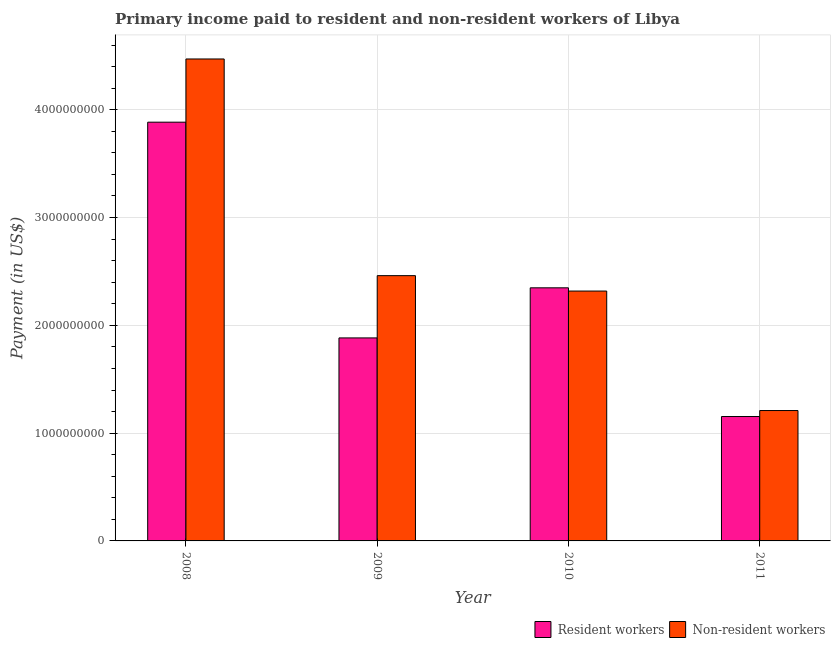How many groups of bars are there?
Ensure brevity in your answer.  4. Are the number of bars per tick equal to the number of legend labels?
Provide a succinct answer. Yes. How many bars are there on the 4th tick from the left?
Give a very brief answer. 2. How many bars are there on the 4th tick from the right?
Give a very brief answer. 2. What is the label of the 1st group of bars from the left?
Ensure brevity in your answer.  2008. In how many cases, is the number of bars for a given year not equal to the number of legend labels?
Give a very brief answer. 0. What is the payment made to non-resident workers in 2009?
Provide a succinct answer. 2.46e+09. Across all years, what is the maximum payment made to resident workers?
Give a very brief answer. 3.88e+09. Across all years, what is the minimum payment made to non-resident workers?
Keep it short and to the point. 1.21e+09. What is the total payment made to non-resident workers in the graph?
Provide a succinct answer. 1.05e+1. What is the difference between the payment made to resident workers in 2009 and that in 2011?
Make the answer very short. 7.29e+08. What is the difference between the payment made to non-resident workers in 2011 and the payment made to resident workers in 2009?
Your answer should be very brief. -1.25e+09. What is the average payment made to resident workers per year?
Make the answer very short. 2.32e+09. In how many years, is the payment made to resident workers greater than 2400000000 US$?
Offer a terse response. 1. What is the ratio of the payment made to resident workers in 2008 to that in 2010?
Your answer should be very brief. 1.65. Is the difference between the payment made to resident workers in 2010 and 2011 greater than the difference between the payment made to non-resident workers in 2010 and 2011?
Provide a short and direct response. No. What is the difference between the highest and the second highest payment made to non-resident workers?
Keep it short and to the point. 2.01e+09. What is the difference between the highest and the lowest payment made to resident workers?
Your answer should be very brief. 2.73e+09. What does the 2nd bar from the left in 2010 represents?
Make the answer very short. Non-resident workers. What does the 1st bar from the right in 2008 represents?
Make the answer very short. Non-resident workers. How many bars are there?
Give a very brief answer. 8. Are all the bars in the graph horizontal?
Keep it short and to the point. No. What is the difference between two consecutive major ticks on the Y-axis?
Your answer should be very brief. 1.00e+09. Are the values on the major ticks of Y-axis written in scientific E-notation?
Keep it short and to the point. No. Does the graph contain grids?
Your answer should be very brief. Yes. How many legend labels are there?
Make the answer very short. 2. How are the legend labels stacked?
Make the answer very short. Horizontal. What is the title of the graph?
Your response must be concise. Primary income paid to resident and non-resident workers of Libya. What is the label or title of the X-axis?
Keep it short and to the point. Year. What is the label or title of the Y-axis?
Your response must be concise. Payment (in US$). What is the Payment (in US$) in Resident workers in 2008?
Give a very brief answer. 3.88e+09. What is the Payment (in US$) in Non-resident workers in 2008?
Offer a very short reply. 4.47e+09. What is the Payment (in US$) in Resident workers in 2009?
Make the answer very short. 1.88e+09. What is the Payment (in US$) of Non-resident workers in 2009?
Your answer should be compact. 2.46e+09. What is the Payment (in US$) of Resident workers in 2010?
Your response must be concise. 2.35e+09. What is the Payment (in US$) of Non-resident workers in 2010?
Make the answer very short. 2.32e+09. What is the Payment (in US$) in Resident workers in 2011?
Your response must be concise. 1.15e+09. What is the Payment (in US$) of Non-resident workers in 2011?
Ensure brevity in your answer.  1.21e+09. Across all years, what is the maximum Payment (in US$) in Resident workers?
Provide a short and direct response. 3.88e+09. Across all years, what is the maximum Payment (in US$) of Non-resident workers?
Provide a short and direct response. 4.47e+09. Across all years, what is the minimum Payment (in US$) of Resident workers?
Provide a short and direct response. 1.15e+09. Across all years, what is the minimum Payment (in US$) of Non-resident workers?
Your answer should be compact. 1.21e+09. What is the total Payment (in US$) in Resident workers in the graph?
Your answer should be very brief. 9.27e+09. What is the total Payment (in US$) in Non-resident workers in the graph?
Provide a succinct answer. 1.05e+1. What is the difference between the Payment (in US$) in Resident workers in 2008 and that in 2009?
Offer a terse response. 2.00e+09. What is the difference between the Payment (in US$) in Non-resident workers in 2008 and that in 2009?
Your answer should be compact. 2.01e+09. What is the difference between the Payment (in US$) in Resident workers in 2008 and that in 2010?
Provide a short and direct response. 1.54e+09. What is the difference between the Payment (in US$) in Non-resident workers in 2008 and that in 2010?
Provide a short and direct response. 2.15e+09. What is the difference between the Payment (in US$) in Resident workers in 2008 and that in 2011?
Ensure brevity in your answer.  2.73e+09. What is the difference between the Payment (in US$) in Non-resident workers in 2008 and that in 2011?
Your response must be concise. 3.26e+09. What is the difference between the Payment (in US$) in Resident workers in 2009 and that in 2010?
Your answer should be very brief. -4.65e+08. What is the difference between the Payment (in US$) in Non-resident workers in 2009 and that in 2010?
Make the answer very short. 1.43e+08. What is the difference between the Payment (in US$) in Resident workers in 2009 and that in 2011?
Give a very brief answer. 7.29e+08. What is the difference between the Payment (in US$) of Non-resident workers in 2009 and that in 2011?
Offer a very short reply. 1.25e+09. What is the difference between the Payment (in US$) in Resident workers in 2010 and that in 2011?
Provide a short and direct response. 1.19e+09. What is the difference between the Payment (in US$) of Non-resident workers in 2010 and that in 2011?
Ensure brevity in your answer.  1.11e+09. What is the difference between the Payment (in US$) of Resident workers in 2008 and the Payment (in US$) of Non-resident workers in 2009?
Offer a very short reply. 1.42e+09. What is the difference between the Payment (in US$) of Resident workers in 2008 and the Payment (in US$) of Non-resident workers in 2010?
Provide a short and direct response. 1.57e+09. What is the difference between the Payment (in US$) in Resident workers in 2008 and the Payment (in US$) in Non-resident workers in 2011?
Keep it short and to the point. 2.68e+09. What is the difference between the Payment (in US$) of Resident workers in 2009 and the Payment (in US$) of Non-resident workers in 2010?
Your answer should be compact. -4.35e+08. What is the difference between the Payment (in US$) in Resident workers in 2009 and the Payment (in US$) in Non-resident workers in 2011?
Your response must be concise. 6.74e+08. What is the difference between the Payment (in US$) of Resident workers in 2010 and the Payment (in US$) of Non-resident workers in 2011?
Your answer should be very brief. 1.14e+09. What is the average Payment (in US$) in Resident workers per year?
Make the answer very short. 2.32e+09. What is the average Payment (in US$) of Non-resident workers per year?
Keep it short and to the point. 2.61e+09. In the year 2008, what is the difference between the Payment (in US$) in Resident workers and Payment (in US$) in Non-resident workers?
Give a very brief answer. -5.86e+08. In the year 2009, what is the difference between the Payment (in US$) of Resident workers and Payment (in US$) of Non-resident workers?
Offer a terse response. -5.78e+08. In the year 2010, what is the difference between the Payment (in US$) of Resident workers and Payment (in US$) of Non-resident workers?
Your answer should be compact. 3.00e+07. In the year 2011, what is the difference between the Payment (in US$) of Resident workers and Payment (in US$) of Non-resident workers?
Your answer should be compact. -5.56e+07. What is the ratio of the Payment (in US$) of Resident workers in 2008 to that in 2009?
Provide a short and direct response. 2.06. What is the ratio of the Payment (in US$) of Non-resident workers in 2008 to that in 2009?
Ensure brevity in your answer.  1.82. What is the ratio of the Payment (in US$) of Resident workers in 2008 to that in 2010?
Provide a succinct answer. 1.65. What is the ratio of the Payment (in US$) of Non-resident workers in 2008 to that in 2010?
Provide a succinct answer. 1.93. What is the ratio of the Payment (in US$) in Resident workers in 2008 to that in 2011?
Your answer should be very brief. 3.37. What is the ratio of the Payment (in US$) of Non-resident workers in 2008 to that in 2011?
Your answer should be very brief. 3.7. What is the ratio of the Payment (in US$) of Resident workers in 2009 to that in 2010?
Provide a succinct answer. 0.8. What is the ratio of the Payment (in US$) in Non-resident workers in 2009 to that in 2010?
Offer a very short reply. 1.06. What is the ratio of the Payment (in US$) in Resident workers in 2009 to that in 2011?
Make the answer very short. 1.63. What is the ratio of the Payment (in US$) of Non-resident workers in 2009 to that in 2011?
Provide a succinct answer. 2.03. What is the ratio of the Payment (in US$) of Resident workers in 2010 to that in 2011?
Your answer should be compact. 2.03. What is the ratio of the Payment (in US$) of Non-resident workers in 2010 to that in 2011?
Provide a succinct answer. 1.92. What is the difference between the highest and the second highest Payment (in US$) of Resident workers?
Your answer should be very brief. 1.54e+09. What is the difference between the highest and the second highest Payment (in US$) in Non-resident workers?
Your answer should be compact. 2.01e+09. What is the difference between the highest and the lowest Payment (in US$) in Resident workers?
Offer a terse response. 2.73e+09. What is the difference between the highest and the lowest Payment (in US$) in Non-resident workers?
Make the answer very short. 3.26e+09. 